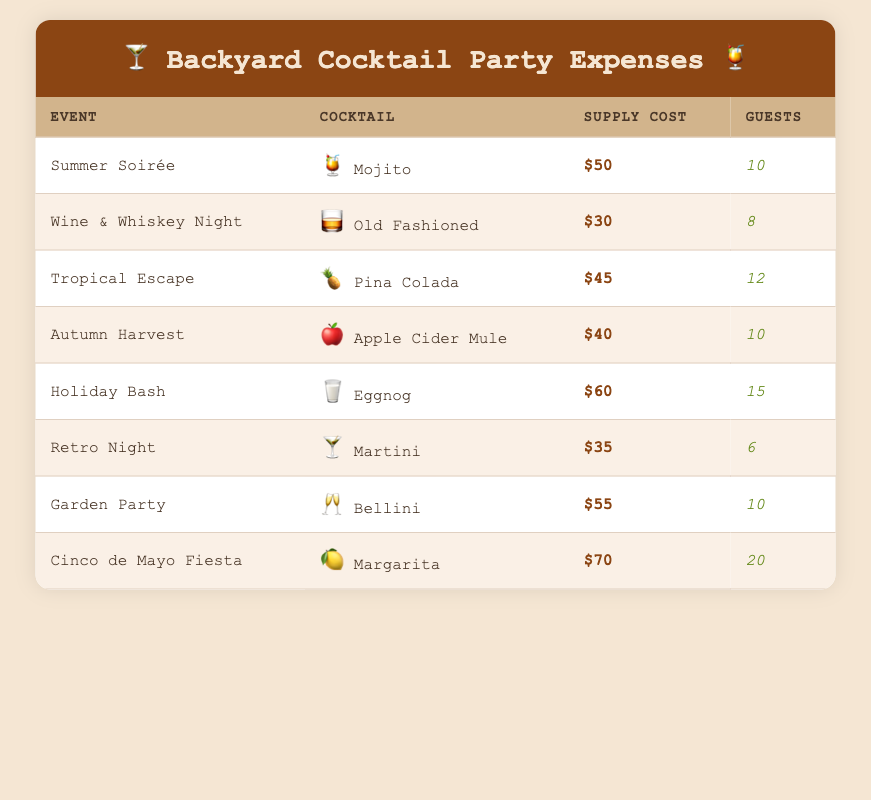What is the supply cost for the Mojito at the Summer Soirée? The table lists the Mojito under the Summer Soirée event, where the Supply Cost is specified as $50.
Answer: $50 How many guests were invited to the Holiday Bash? The Holiday Bash event shows a Guest Count of 15 directly listed in the table.
Answer: 15 Which cocktail had the highest supply cost? By reviewing the Supply Cost column, the Margarita associated with the Cinco de Mayo Fiesta has the highest amount at $70.
Answer: Margarita What is the average supply cost per guest for the Tropical Escape? For the Tropical Escape, the supply cost is $45, and the guest count is 12. To find the average: 45 / 12 = 3.75.
Answer: 3.75 Did the Retro Night cost more than the Garden Party? The Retro Night has a supply cost of $35, while the Garden Party has a cost of $55. Since 35 is less than 55, the answer is no.
Answer: No What is the total supply cost for all events? Adding up all the supply costs: 50 + 30 + 45 + 40 + 60 + 35 + 55 + 70 = 385. Therefore, the total supply cost is $385.
Answer: $385 Which event had the lowest average spending on supplies per guest? For each event, we need to calculate the average spending per guest. The lowest is found in Wine & Whiskey Night with $30 for 8 guests, making it $3.75 per guest. Comparatively, other events have a higher cost per guest.
Answer: Wine & Whiskey Night How many guests were there in total across all events? We sum up the Guest Count column: 10 + 8 + 12 + 10 + 15 + 6 + 10 + 20 = 91. This gives us the total guest count across all events.
Answer: 91 Which cocktail had a supply cost per guest that was higher than $6? For each cocktail, dividing the supply cost by the guest count indicates that the only cocktail with a higher cost per guest than $6 is the Margarita, with $70 for 20 guests yielding $3.50, which is less than $6.
Answer: No 